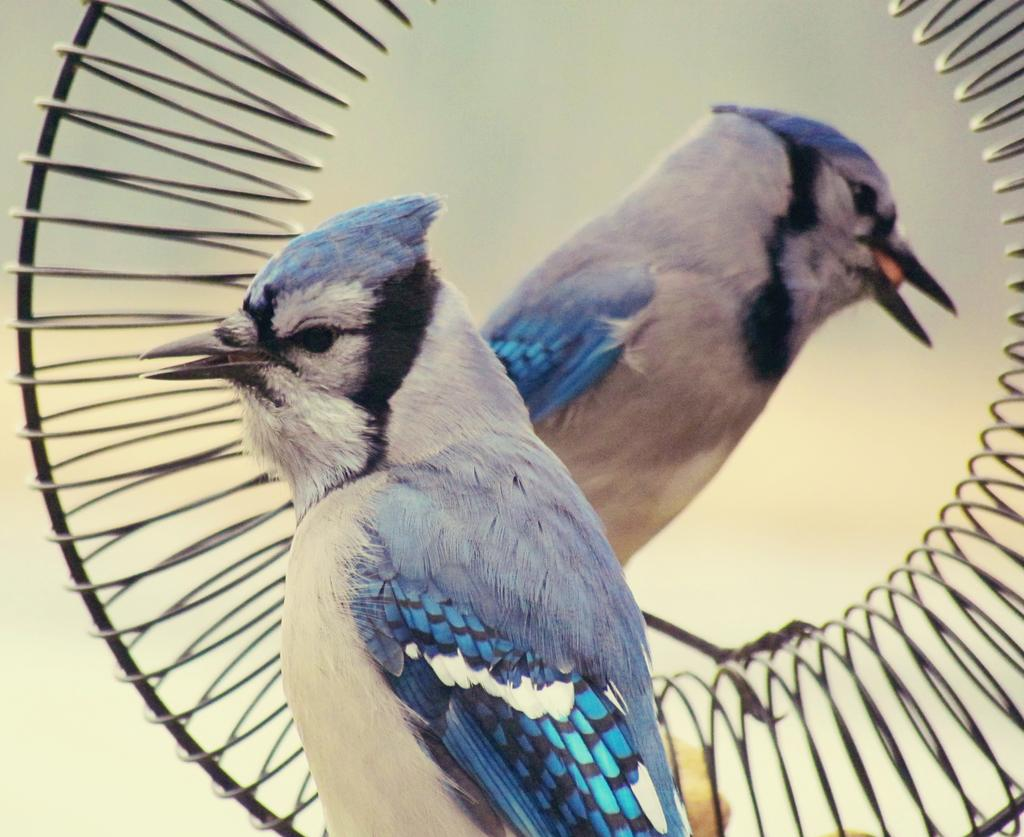How many birds are present in the image? There are two birds in the image. What can be seen in the background of the image? There is an object with a round shape in the background. How would you describe the background of the image? The background of the image is blurred. What type of stem can be seen growing from the birds in the image? There are no stems present in the image, and the birds are not associated with any plants or growth. 